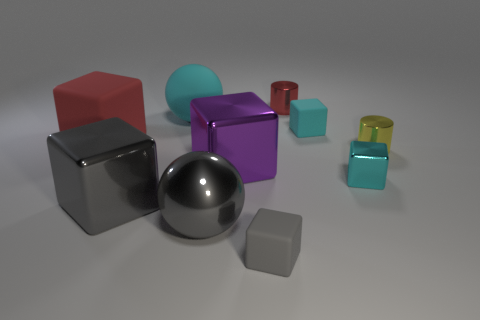Subtract 1 blocks. How many blocks are left? 5 Subtract all red cubes. How many cubes are left? 5 Subtract all small gray matte cubes. How many cubes are left? 5 Subtract all green blocks. Subtract all blue spheres. How many blocks are left? 6 Subtract all balls. How many objects are left? 8 Add 4 tiny gray things. How many tiny gray things exist? 5 Subtract 0 blue cylinders. How many objects are left? 10 Subtract all tiny gray matte objects. Subtract all small metallic cylinders. How many objects are left? 7 Add 6 big red objects. How many big red objects are left? 7 